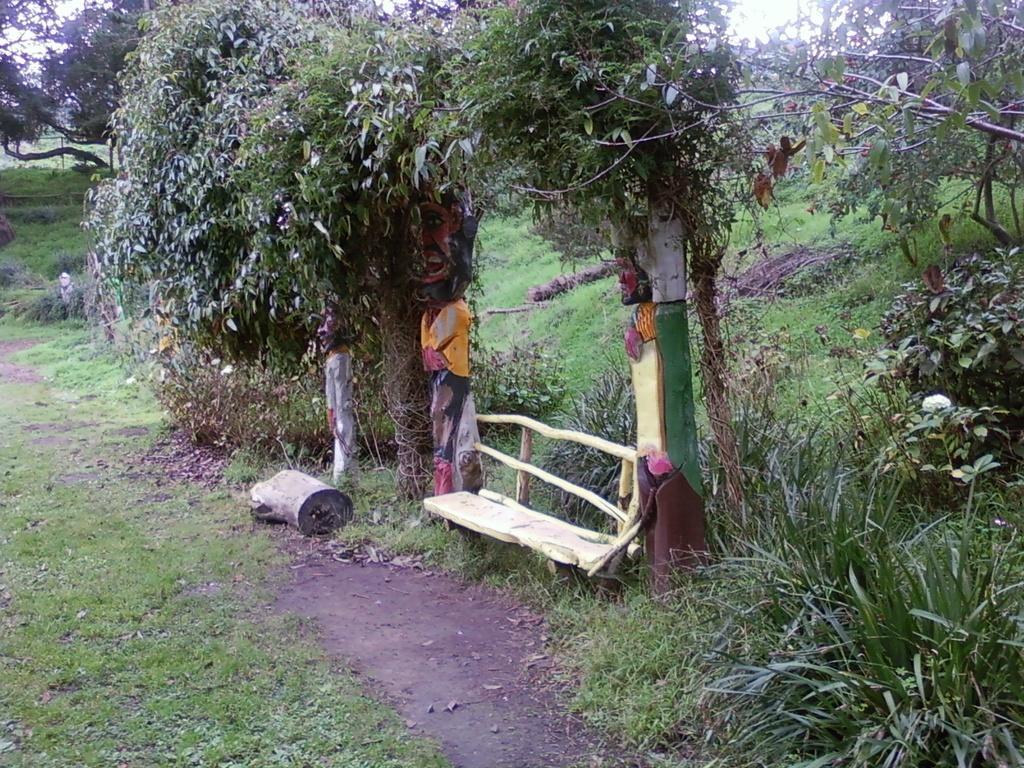In one or two sentences, can you explain what this image depicts? In this picture we can see the trees, plants and the green grass. We can see a wooden log on the ground. We can see a wooden bench. We can see the carved wooden pillars and we can see the painting on them. 